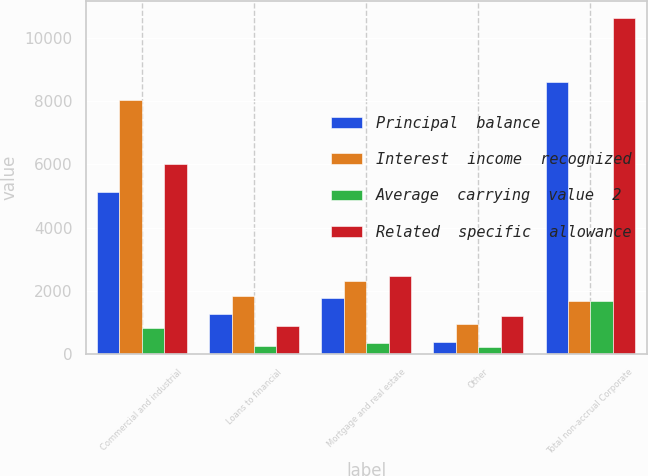Convert chart to OTSL. <chart><loc_0><loc_0><loc_500><loc_500><stacked_bar_chart><ecel><fcel>Commercial and industrial<fcel>Loans to financial<fcel>Mortgage and real estate<fcel>Other<fcel>Total non-accrual Corporate<nl><fcel>Principal  balance<fcel>5125<fcel>1258<fcel>1782<fcel>400<fcel>8610<nl><fcel>Interest  income  recognized<fcel>8021<fcel>1835<fcel>2328<fcel>948<fcel>1689<nl><fcel>Average  carrying  value  2<fcel>843<fcel>259<fcel>369<fcel>218<fcel>1689<nl><fcel>Related  specific  allowance<fcel>6016<fcel>883<fcel>2474<fcel>1205<fcel>10633<nl></chart> 